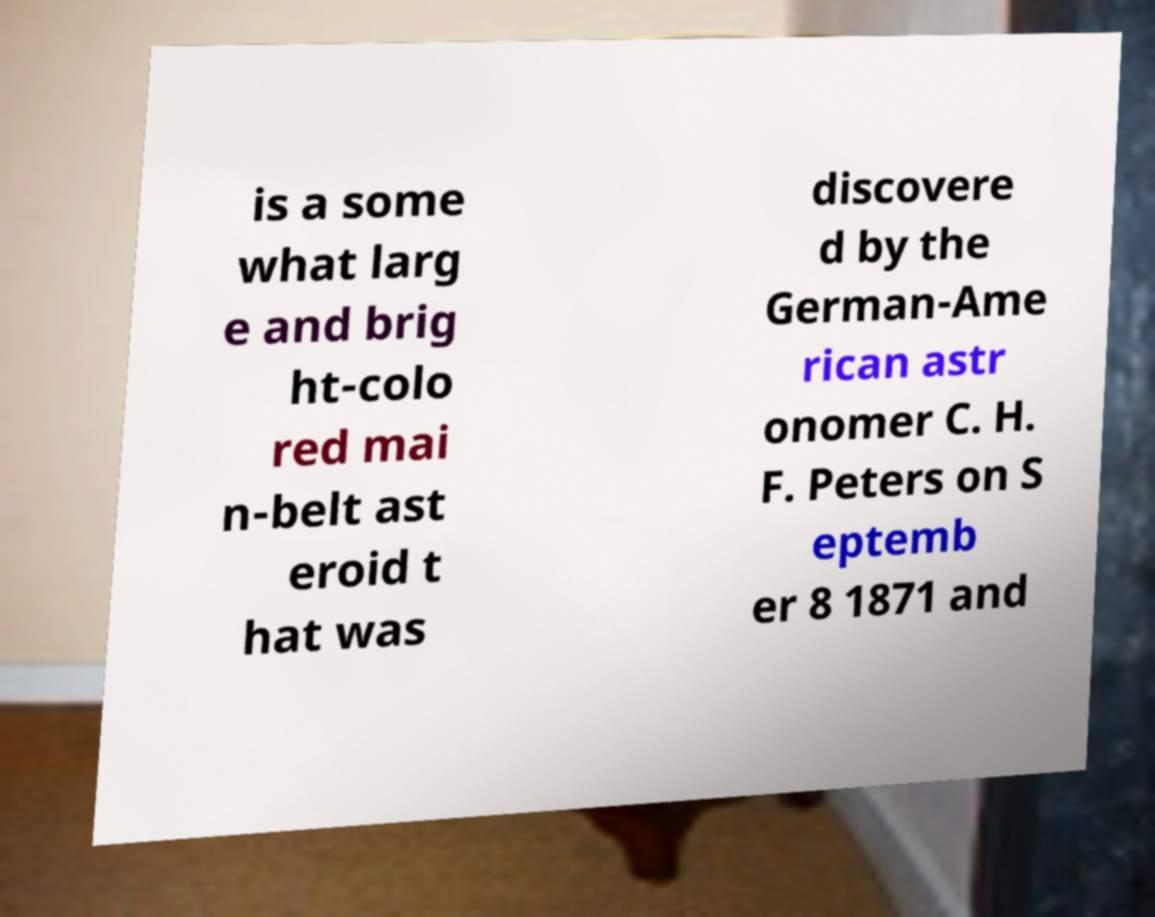I need the written content from this picture converted into text. Can you do that? is a some what larg e and brig ht-colo red mai n-belt ast eroid t hat was discovere d by the German-Ame rican astr onomer C. H. F. Peters on S eptemb er 8 1871 and 